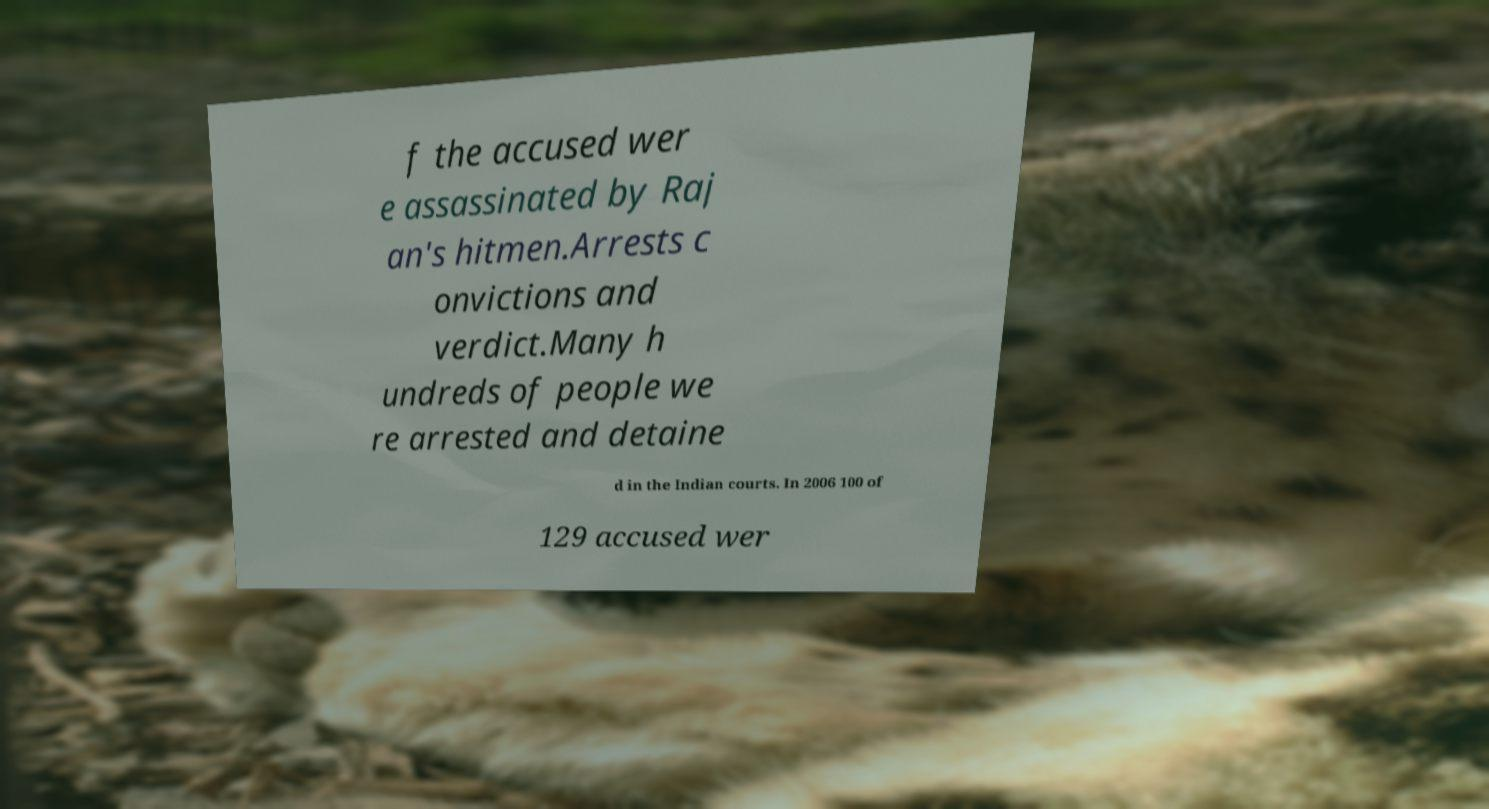I need the written content from this picture converted into text. Can you do that? f the accused wer e assassinated by Raj an's hitmen.Arrests c onvictions and verdict.Many h undreds of people we re arrested and detaine d in the Indian courts. In 2006 100 of 129 accused wer 